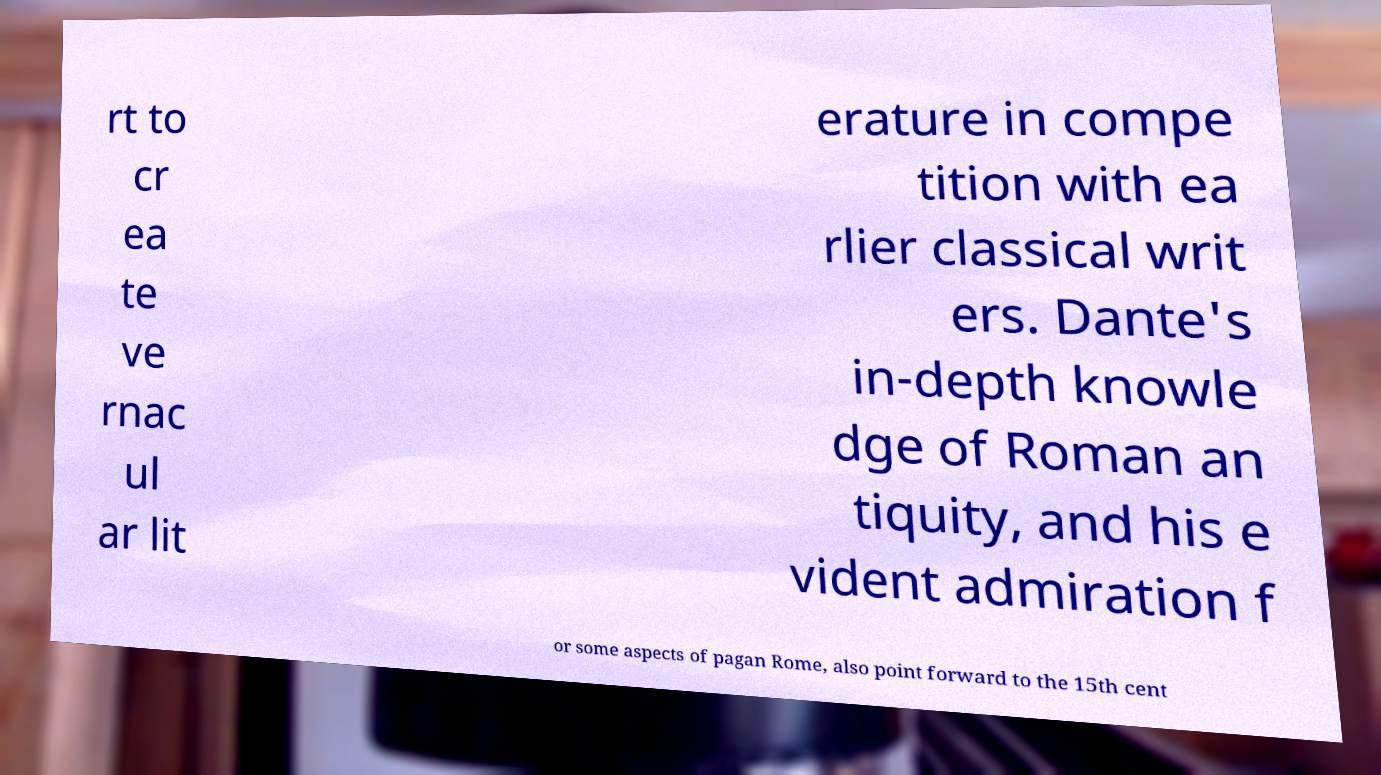Please identify and transcribe the text found in this image. rt to cr ea te ve rnac ul ar lit erature in compe tition with ea rlier classical writ ers. Dante's in-depth knowle dge of Roman an tiquity, and his e vident admiration f or some aspects of pagan Rome, also point forward to the 15th cent 